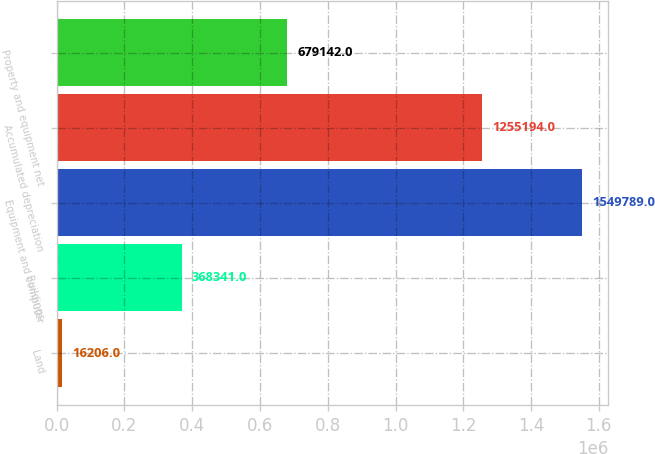Convert chart. <chart><loc_0><loc_0><loc_500><loc_500><bar_chart><fcel>Land<fcel>Buildings<fcel>Equipment and computer<fcel>Accumulated depreciation<fcel>Property and equipment net<nl><fcel>16206<fcel>368341<fcel>1.54979e+06<fcel>1.25519e+06<fcel>679142<nl></chart> 